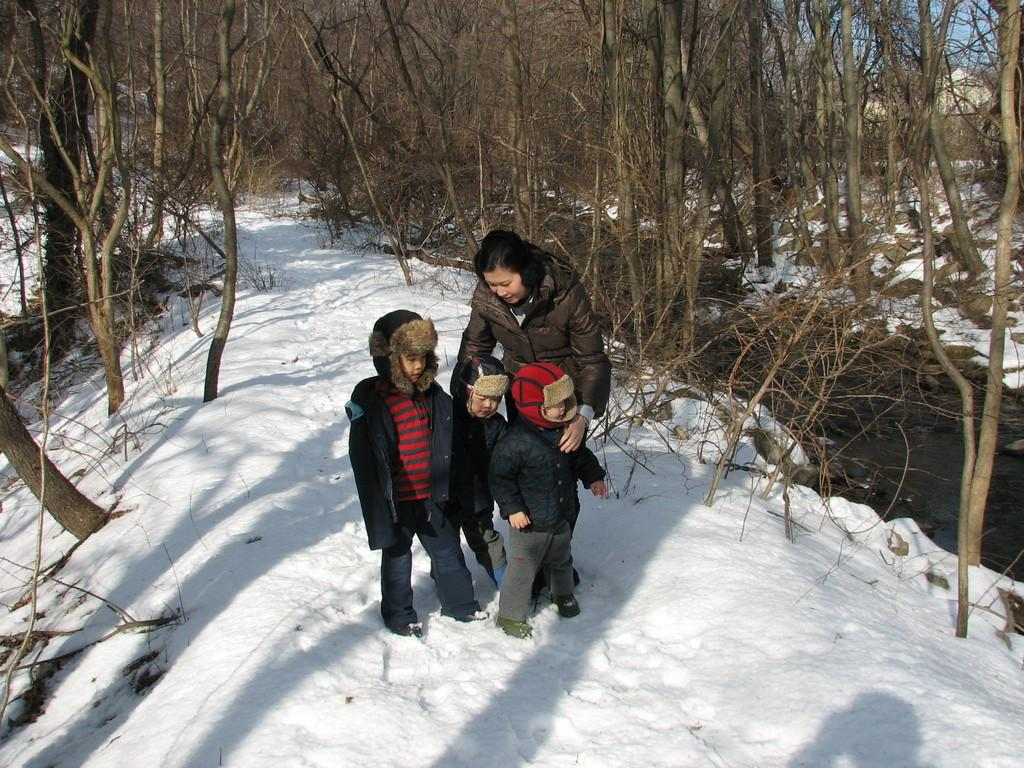How many kids are in the image? There are three kids on the ground in the image. Who else is on the ground with the kids? There is a woman on the ground in the image. What type of clothing are the individuals wearing? All the individuals are wearing winter clothes. What is the ground condition in the image? There is snow on the ground in the image. What can be seen in the background of the image? There are trees and a building in the background of the image. What is the rate of disgust expressed by the drum in the image? There is no drum present in the image, and therefore no rate of disgust can be determined. 